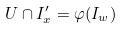Convert formula to latex. <formula><loc_0><loc_0><loc_500><loc_500>U \cap I _ { x } ^ { \prime } = \varphi ( I _ { w } )</formula> 